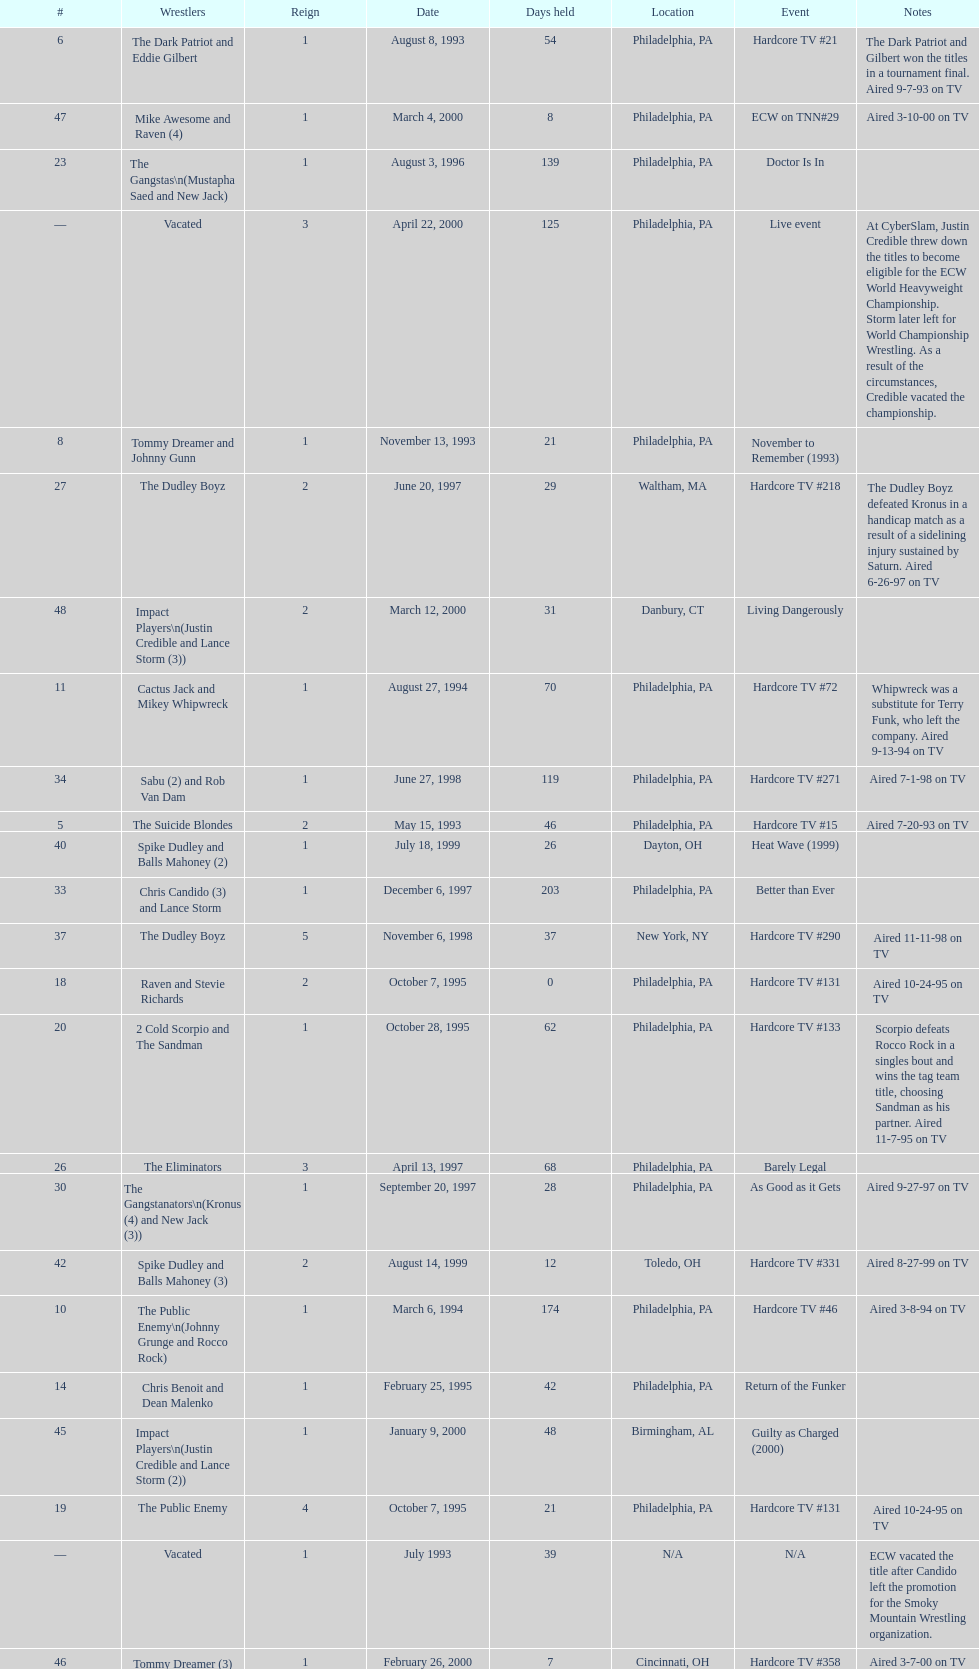What is the next event after hardcore tv #15? Hardcore TV #21. 